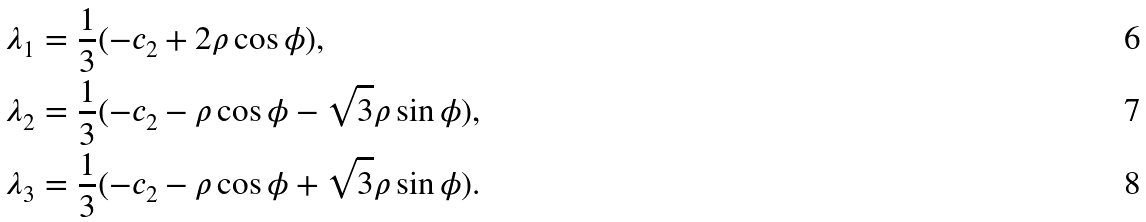<formula> <loc_0><loc_0><loc_500><loc_500>\lambda _ { 1 } & = \frac { 1 } { 3 } ( - c _ { 2 } + 2 \rho \cos \phi ) , \\ \lambda _ { 2 } & = \frac { 1 } { 3 } ( - c _ { 2 } - \rho \cos \phi - \sqrt { 3 } \rho \sin \phi ) , \\ \lambda _ { 3 } & = \frac { 1 } { 3 } ( - c _ { 2 } - \rho \cos \phi + \sqrt { 3 } \rho \sin \phi ) .</formula> 